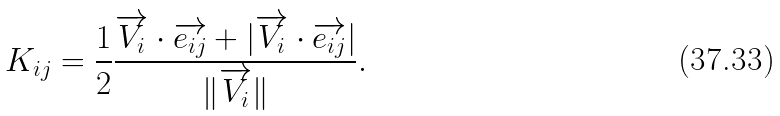Convert formula to latex. <formula><loc_0><loc_0><loc_500><loc_500>K _ { i j } = \frac { 1 } { 2 } \frac { \overrightarrow { V _ { i } } \cdot \overrightarrow { e _ { i j } } + | \overrightarrow { V _ { i } } \cdot \overrightarrow { e _ { i j } } | } { \| \overrightarrow { V _ { i } } \| } .</formula> 